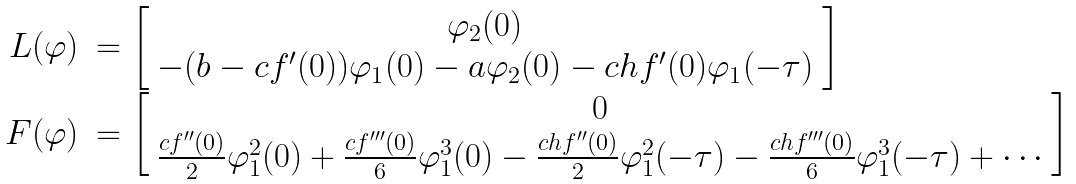<formula> <loc_0><loc_0><loc_500><loc_500>\begin{array} { r l } L ( \varphi ) & = \left [ \begin{array} { c } \varphi _ { 2 } ( 0 ) \\ - ( b - c f ^ { \prime } ( 0 ) ) \varphi _ { 1 } ( 0 ) - a \varphi _ { 2 } ( 0 ) - c h f ^ { \prime } ( 0 ) \varphi _ { 1 } ( - \tau ) \end{array} \right ] \\ F ( \varphi ) & = \left [ \begin{array} { c } 0 \\ \frac { c f ^ { \prime \prime } ( 0 ) } { 2 } \varphi _ { 1 } ^ { 2 } ( 0 ) + \frac { c f ^ { \prime \prime \prime } ( 0 ) } { 6 } \varphi _ { 1 } ^ { 3 } ( 0 ) - \frac { c h f ^ { \prime \prime } ( 0 ) } { 2 } \varphi _ { 1 } ^ { 2 } ( - \tau ) - \frac { c h f ^ { \prime \prime \prime } ( 0 ) } { 6 } \varphi _ { 1 } ^ { 3 } ( - \tau ) + \cdots \end{array} \right ] \end{array}</formula> 